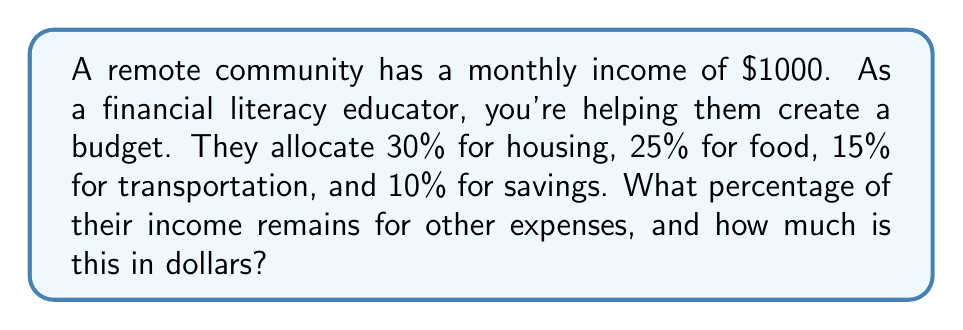What is the answer to this math problem? To solve this problem, we'll follow these steps:

1. Calculate the total percentage allocated to known categories:
   $$30\% + 25\% + 15\% + 10\% = 80\%$$

2. Determine the remaining percentage:
   $$100\% - 80\% = 20\%$$

3. Calculate the dollar amount for the remaining percentage:
   $$20\% \text{ of } \$1000 = 0.20 \times \$1000 = \$200$$

The remaining percentage is 20%, which amounts to $200.

This calculation demonstrates the importance of budgeting and allocating funds to various expense categories. It also shows how to determine the remaining amount for discretionary spending or additional savings.
Answer: 20% remains for other expenses, which is $200. 